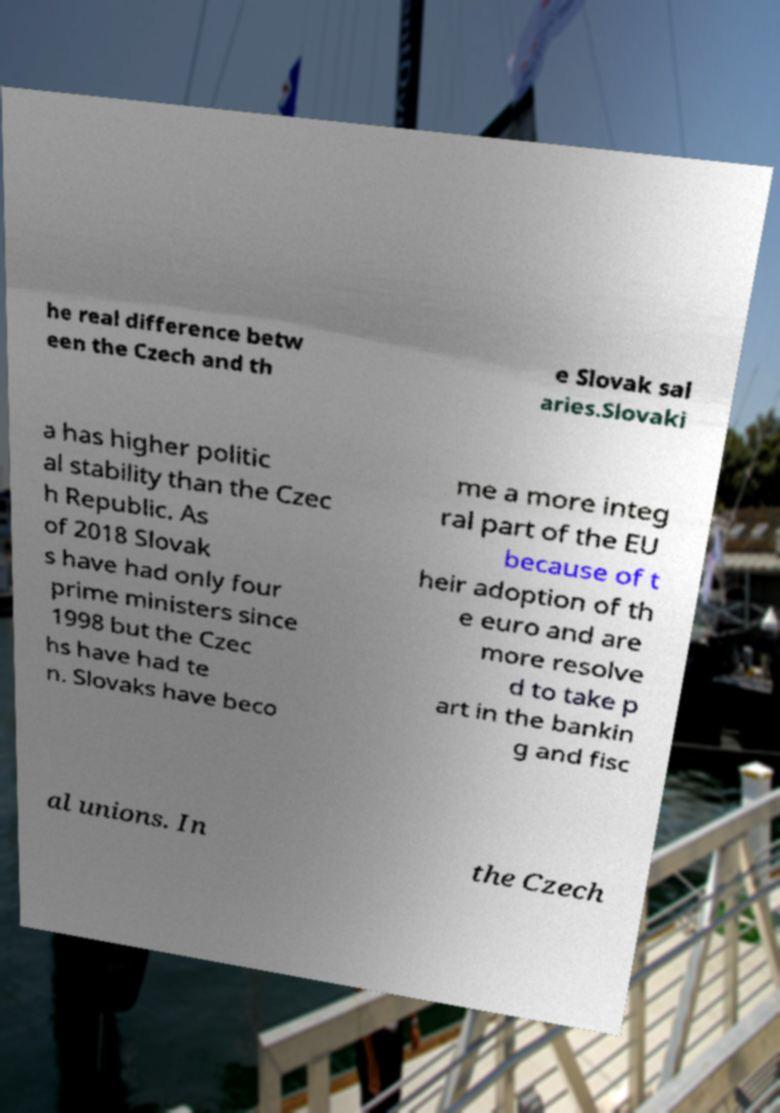What messages or text are displayed in this image? I need them in a readable, typed format. he real difference betw een the Czech and th e Slovak sal aries.Slovaki a has higher politic al stability than the Czec h Republic. As of 2018 Slovak s have had only four prime ministers since 1998 but the Czec hs have had te n. Slovaks have beco me a more integ ral part of the EU because of t heir adoption of th e euro and are more resolve d to take p art in the bankin g and fisc al unions. In the Czech 